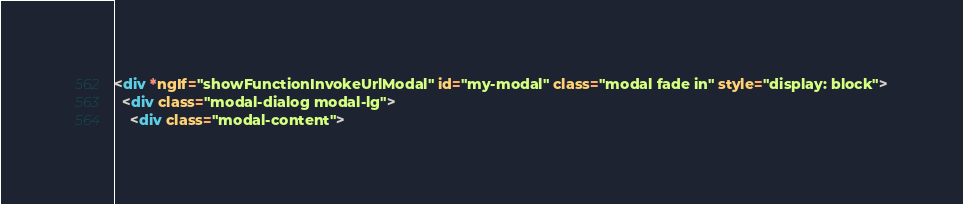Convert code to text. <code><loc_0><loc_0><loc_500><loc_500><_HTML_><div *ngIf="showFunctionInvokeUrlModal" id="my-modal" class="modal fade in" style="display: block">
  <div class="modal-dialog modal-lg">
    <div class="modal-content"></code> 